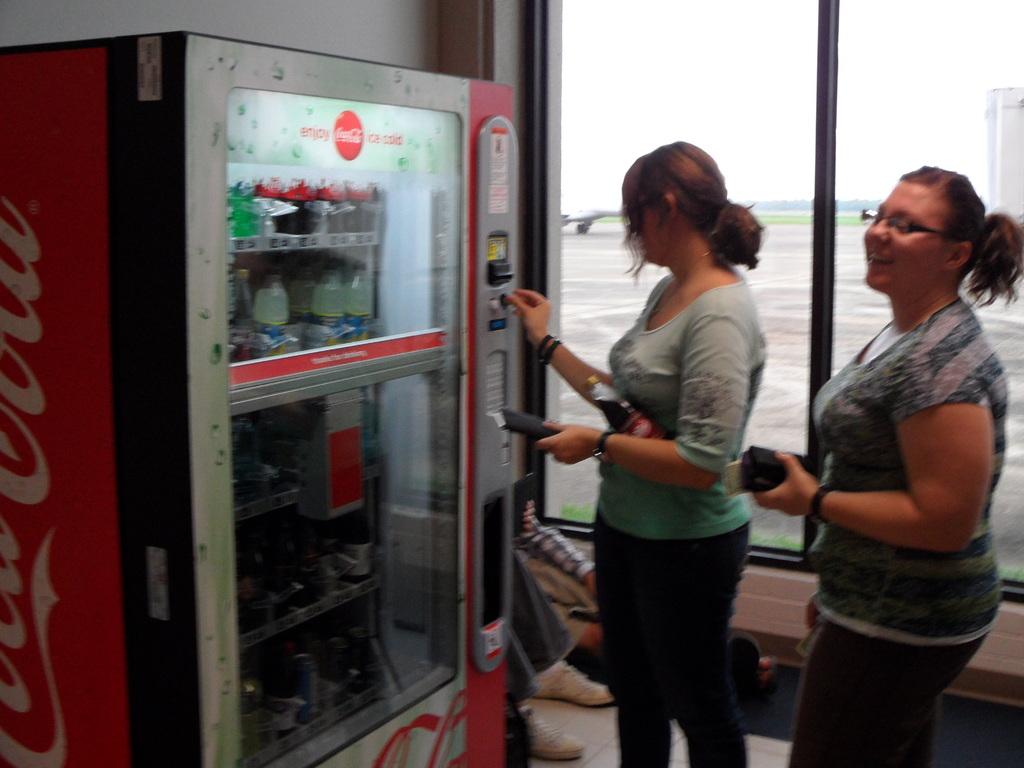What drink should one enjoy ice cold?
Give a very brief answer. Coca-cola. What should you do with an ice cold coke?
Your answer should be very brief. Enjoy. 